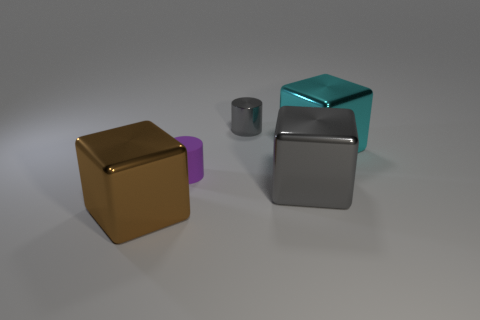What color is the rubber object?
Provide a short and direct response. Purple. What number of things are behind the large gray cube and on the left side of the cyan metallic block?
Offer a very short reply. 2. What number of other things are there of the same material as the gray block
Your answer should be compact. 3. Does the big thing that is behind the rubber cylinder have the same material as the gray cube?
Make the answer very short. Yes. What is the size of the shiny object behind the block behind the gray object that is right of the gray metal cylinder?
Provide a succinct answer. Small. What number of other things are the same color as the matte thing?
Provide a succinct answer. 0. What is the shape of the shiny object that is the same size as the purple matte thing?
Your answer should be very brief. Cylinder. What is the size of the block behind the small matte cylinder?
Your answer should be compact. Large. There is a cube behind the tiny purple cylinder; is its color the same as the big metallic object to the left of the big gray thing?
Make the answer very short. No. There is a thing in front of the gray metallic object that is in front of the gray thing that is behind the large cyan cube; what is it made of?
Your answer should be very brief. Metal. 